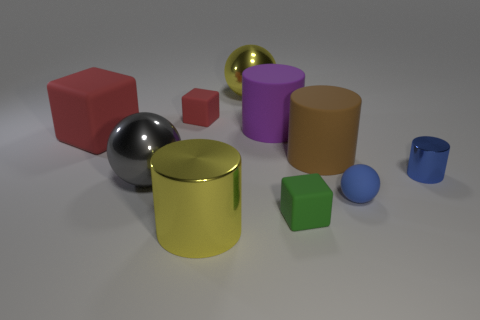Is there any other thing that has the same size as the purple object?
Offer a very short reply. Yes. Is the number of tiny gray matte cubes greater than the number of large yellow cylinders?
Offer a terse response. No. There is a rubber block that is on the left side of the tiny green matte cube and right of the big red matte block; what size is it?
Keep it short and to the point. Small. The large brown object is what shape?
Provide a short and direct response. Cylinder. How many purple objects have the same shape as the big red rubber object?
Keep it short and to the point. 0. Is the number of purple objects that are in front of the small green cube less than the number of purple matte cylinders that are in front of the small shiny thing?
Provide a short and direct response. No. How many large things are right of the rubber cylinder on the left side of the small green matte thing?
Offer a terse response. 1. Are there any blue spheres?
Make the answer very short. Yes. Is there a large brown cylinder that has the same material as the small red thing?
Your response must be concise. Yes. Is the number of rubber blocks that are behind the gray thing greater than the number of yellow objects behind the tiny blue cylinder?
Ensure brevity in your answer.  Yes. 